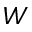Convert formula to latex. <formula><loc_0><loc_0><loc_500><loc_500>W</formula> 